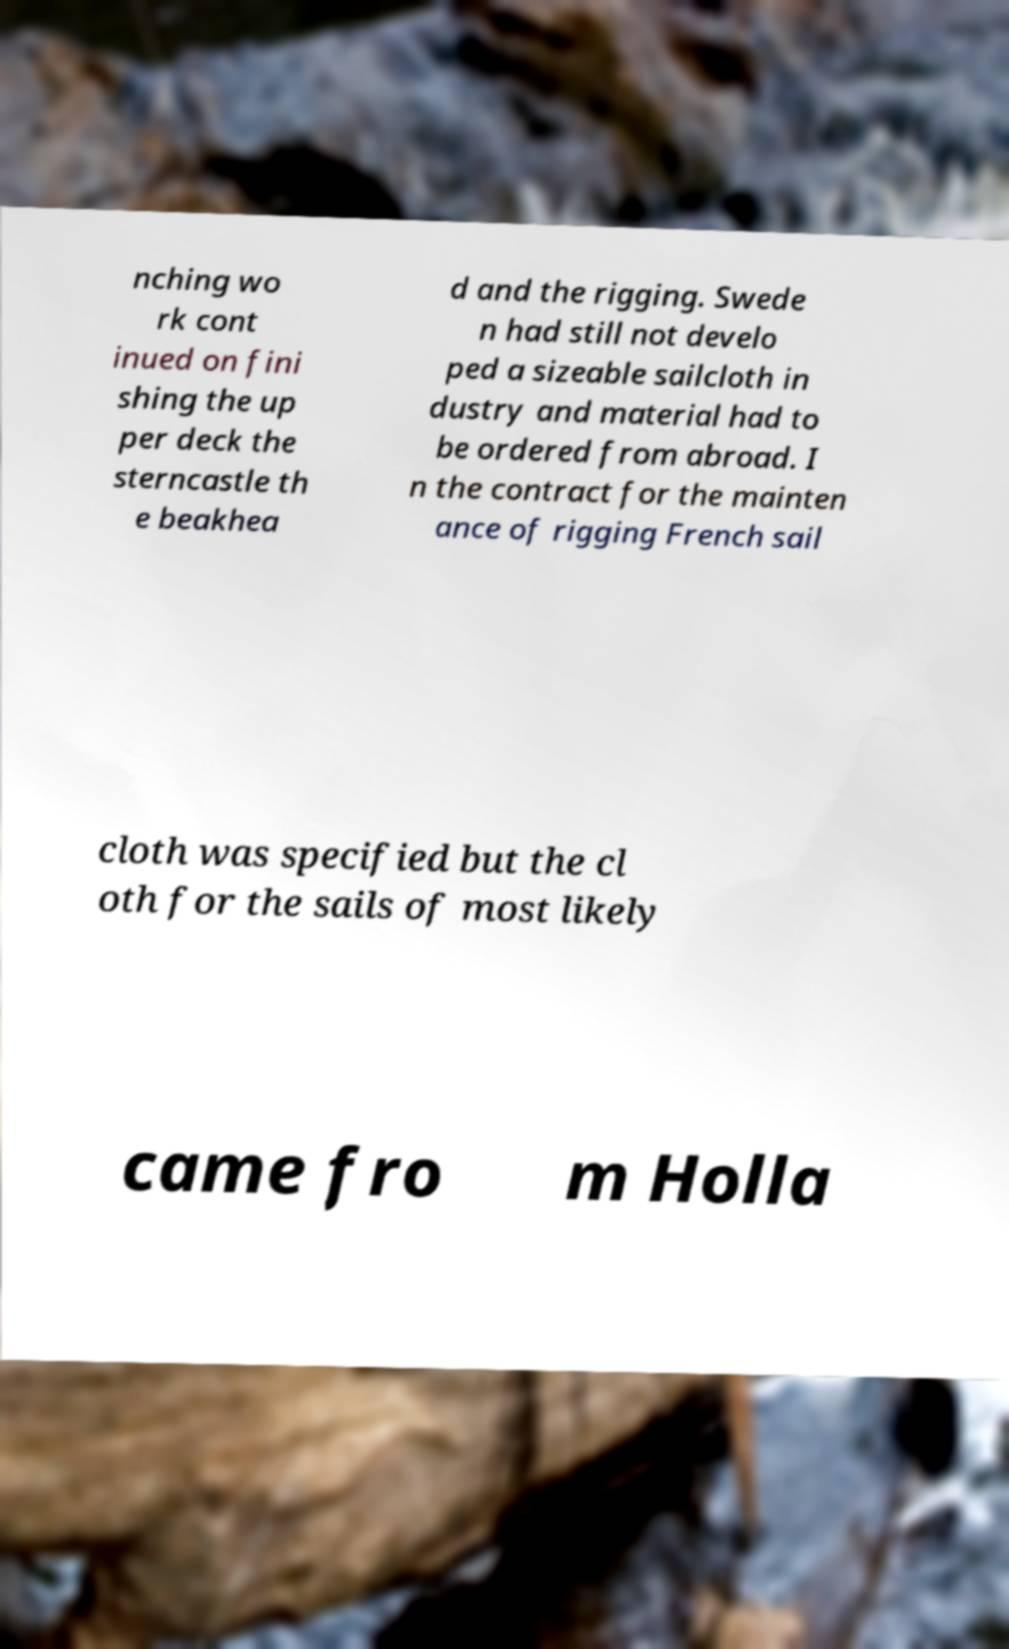Could you assist in decoding the text presented in this image and type it out clearly? nching wo rk cont inued on fini shing the up per deck the sterncastle th e beakhea d and the rigging. Swede n had still not develo ped a sizeable sailcloth in dustry and material had to be ordered from abroad. I n the contract for the mainten ance of rigging French sail cloth was specified but the cl oth for the sails of most likely came fro m Holla 